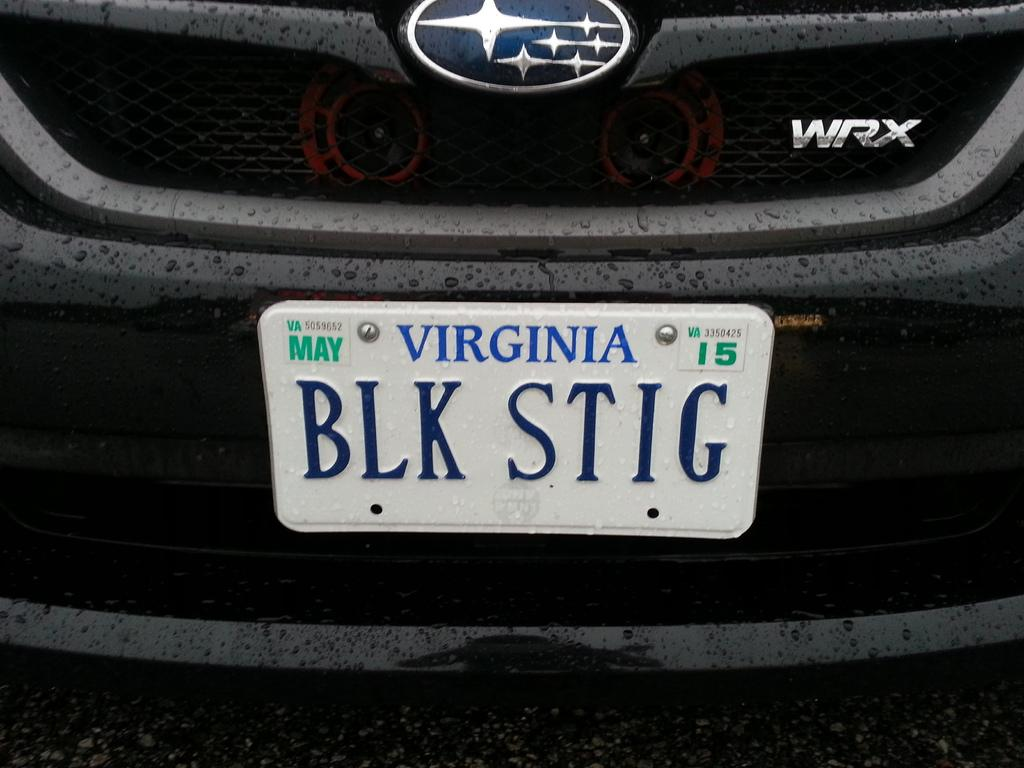<image>
Relay a brief, clear account of the picture shown. A car has the Virginia license plate BLK STIG. 